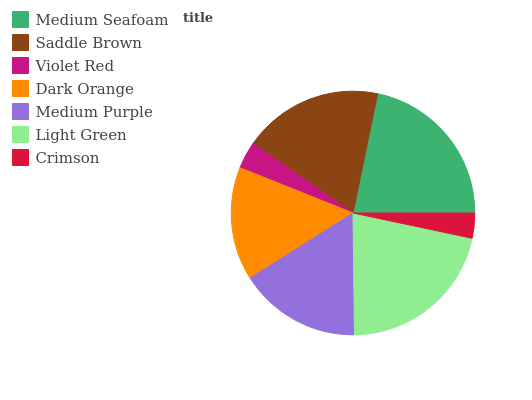Is Crimson the minimum?
Answer yes or no. Yes. Is Medium Seafoam the maximum?
Answer yes or no. Yes. Is Saddle Brown the minimum?
Answer yes or no. No. Is Saddle Brown the maximum?
Answer yes or no. No. Is Medium Seafoam greater than Saddle Brown?
Answer yes or no. Yes. Is Saddle Brown less than Medium Seafoam?
Answer yes or no. Yes. Is Saddle Brown greater than Medium Seafoam?
Answer yes or no. No. Is Medium Seafoam less than Saddle Brown?
Answer yes or no. No. Is Medium Purple the high median?
Answer yes or no. Yes. Is Medium Purple the low median?
Answer yes or no. Yes. Is Light Green the high median?
Answer yes or no. No. Is Saddle Brown the low median?
Answer yes or no. No. 